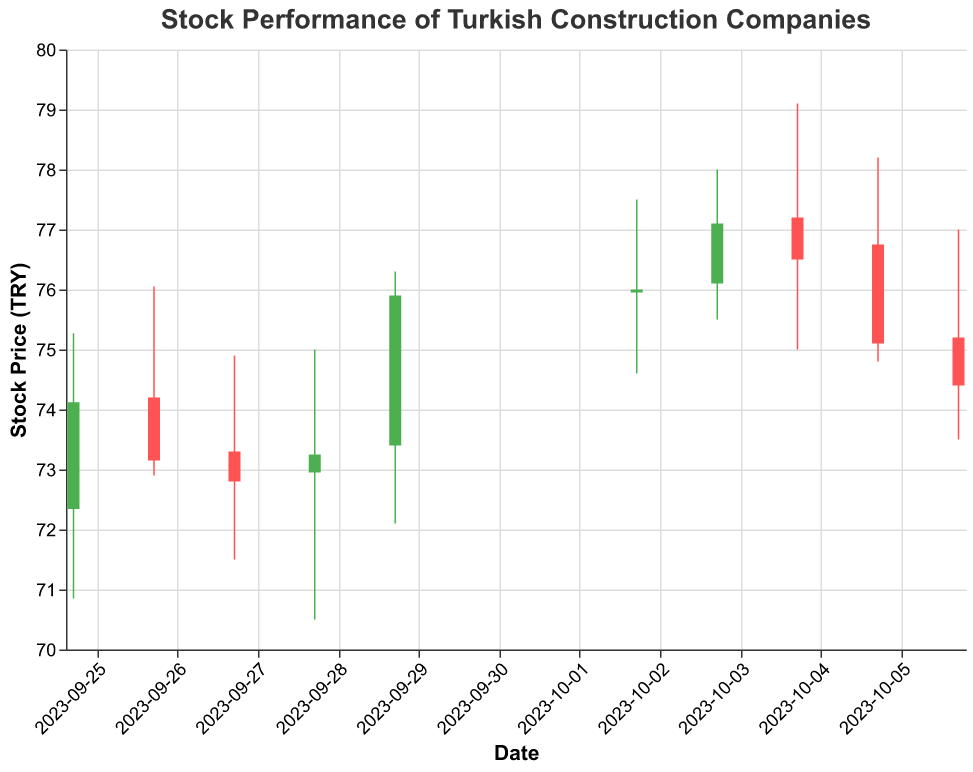What is the title of the plot? The title of the plot is found at the top and it indicates what the plot is about.
Answer: Stock Performance of Turkish Construction Companies How many companies' stock performance are displayed in the plot? By counting the unique company names in the data, we can determine the number of companies displayed.
Answer: 10 What are the highest and lowest stock prices for Nurol Construction? Look for the data point corresponding to Nurol Construction and note the high and low prices for the corresponding date.
Answer: High: 78.00, Low: 75.50 Which company had the highest closing price during the time period? Compare the closing prices of all companies to find the highest one.
Answer: Nurol Construction on 2023-10-03 with a closing price of 77.10 What was the average closing price of the stocks on October 2nd? Add the closing prices of all companies on October 2nd and divide by the number of companies.
Answer: 76.00 Which company's stock opened higher on October 5th, YDA Group or Artaş Construction? Compare the opening prices of YDA Group and Artaş Construction on October 5th.
Answer: YDA Group (76.75 vs 75.20) Did any stock price close higher than it opened on September 29th? Observe the bars on September 29th; a green bar indicates a close higher than the open.
Answer: Yes, Cengiz Holding What is the trend of the closing prices for ENKA Insaat from September 25 to October 6? Note the closing prices of ENKA Insaat for each date and analyze the trend over time.
Answer: Increasing from 75.90 to 76.00 Which day had the highest overall trading volume? Look at the volume values for each date and find the highest one.
Answer: September 28 with 1,650,000 How much did the stock price of Suryap Construction change from opening to closing on September 28? Subtract the closing price from the opening price for Suryap Construction on September 28.
Answer: 0.30 (73.25 - 72.95) 